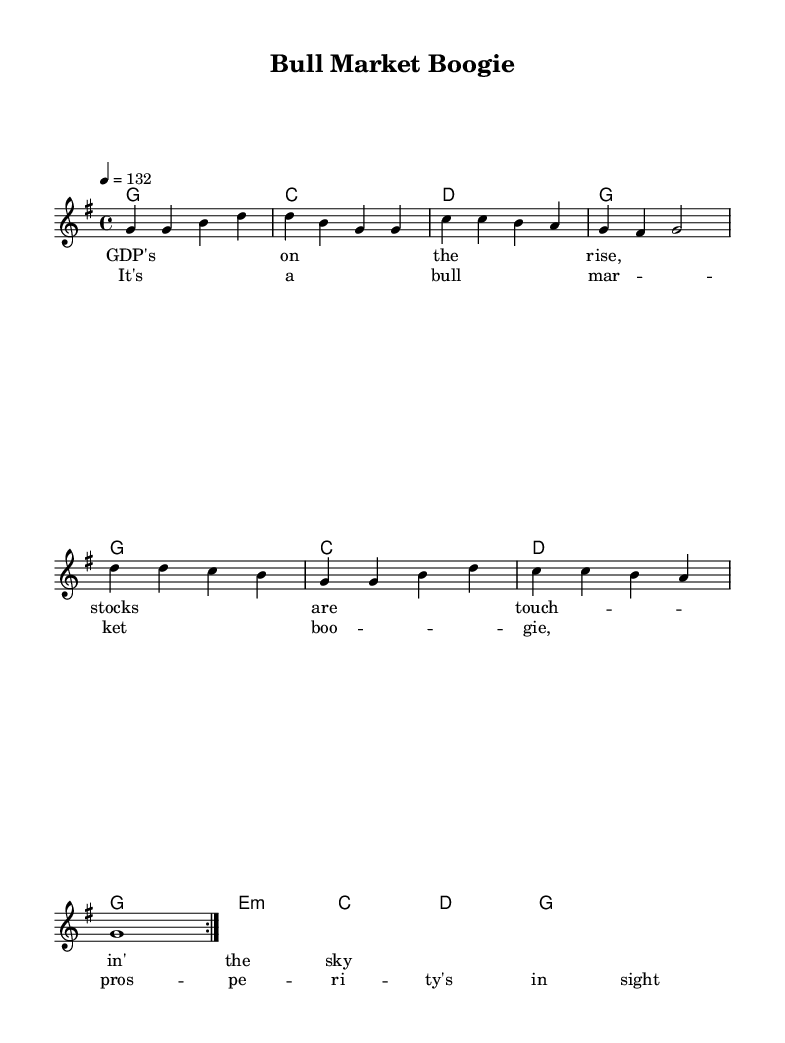What is the key signature of this music? The key signature is G major, indicated by one sharp (F#) in the key signature display.
Answer: G major What is the time signature of this music? The time signature is indicated at the beginning of the score and displays four beats per measure, noted as 4/4.
Answer: 4/4 What is the tempo marking of this piece? The tempo marking shows a quarter note equals 132 beats per minute, indicating the speed of the piece.
Answer: 132 How many verses are repeated in the melody? The sheet shows a repeat sign (volta) indicating that the verse is played twice, which means the first section of the melody repeats fully before moving on.
Answer: 2 What type of economic concept is celebrated in the lyrics? The lyrics celebrate the rise of GDP and a booming stock market, emphasizing economic growth and prosperity, as reflected in the repetitive nature of the lyrics.
Answer: Prosperity What is the primary mood conveyed by the song's title? The title "Bull Market Boogie" implies a lively and upbeat celebration of economic success, using the term "Bull Market" commonly associated with rising stock prices.
Answer: Upbeat What chord follows the last note in the chorus? The last note of the chorus melody is supported by a G chord, as indicated in the harmonies just below the melody line.
Answer: G 